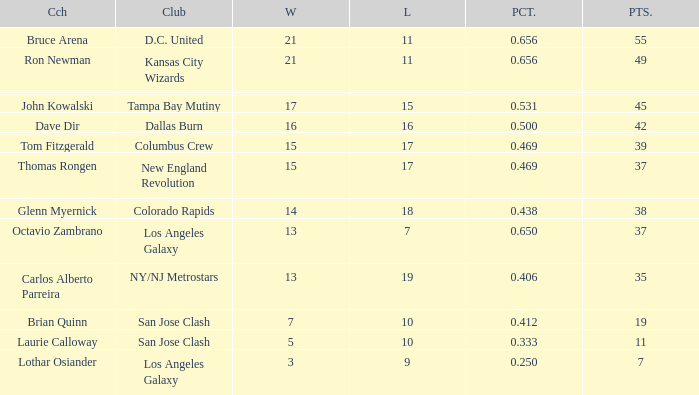What is the sum of points when Bruce Arena has 21 wins? 55.0. Parse the full table. {'header': ['Cch', 'Club', 'W', 'L', 'PCT.', 'PTS.'], 'rows': [['Bruce Arena', 'D.C. United', '21', '11', '0.656', '55'], ['Ron Newman', 'Kansas City Wizards', '21', '11', '0.656', '49'], ['John Kowalski', 'Tampa Bay Mutiny', '17', '15', '0.531', '45'], ['Dave Dir', 'Dallas Burn', '16', '16', '0.500', '42'], ['Tom Fitzgerald', 'Columbus Crew', '15', '17', '0.469', '39'], ['Thomas Rongen', 'New England Revolution', '15', '17', '0.469', '37'], ['Glenn Myernick', 'Colorado Rapids', '14', '18', '0.438', '38'], ['Octavio Zambrano', 'Los Angeles Galaxy', '13', '7', '0.650', '37'], ['Carlos Alberto Parreira', 'NY/NJ Metrostars', '13', '19', '0.406', '35'], ['Brian Quinn', 'San Jose Clash', '7', '10', '0.412', '19'], ['Laurie Calloway', 'San Jose Clash', '5', '10', '0.333', '11'], ['Lothar Osiander', 'Los Angeles Galaxy', '3', '9', '0.250', '7']]} 